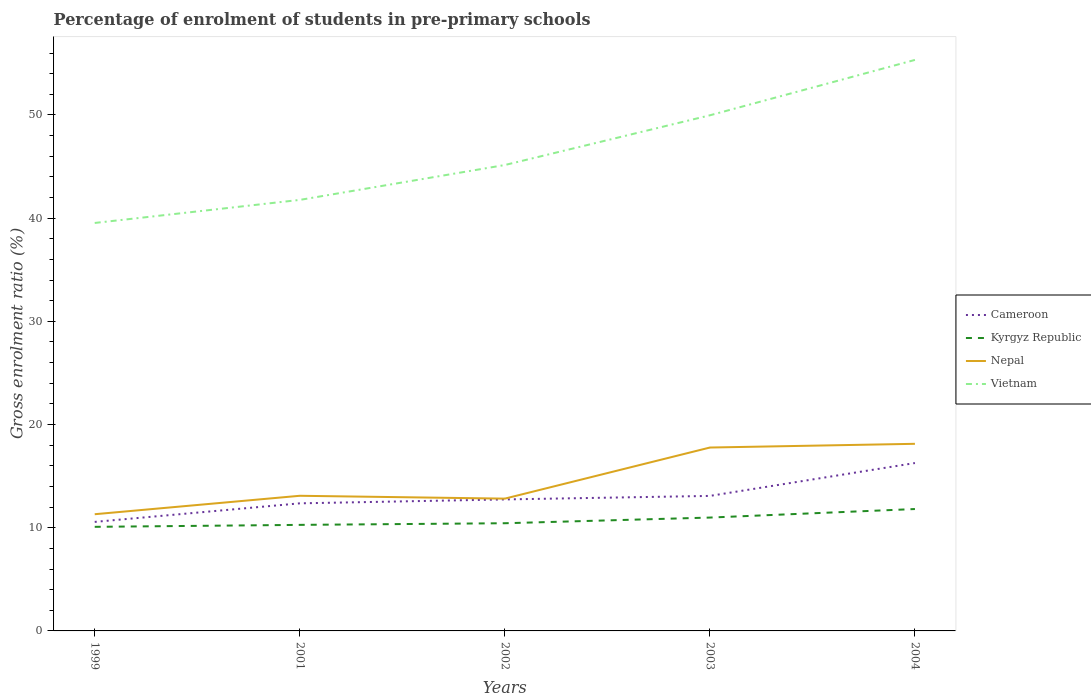How many different coloured lines are there?
Offer a terse response. 4. Across all years, what is the maximum percentage of students enrolled in pre-primary schools in Nepal?
Offer a terse response. 11.31. In which year was the percentage of students enrolled in pre-primary schools in Vietnam maximum?
Offer a terse response. 1999. What is the total percentage of students enrolled in pre-primary schools in Cameroon in the graph?
Give a very brief answer. -3.19. What is the difference between the highest and the second highest percentage of students enrolled in pre-primary schools in Kyrgyz Republic?
Keep it short and to the point. 1.73. Is the percentage of students enrolled in pre-primary schools in Nepal strictly greater than the percentage of students enrolled in pre-primary schools in Kyrgyz Republic over the years?
Make the answer very short. No. How many years are there in the graph?
Keep it short and to the point. 5. What is the difference between two consecutive major ticks on the Y-axis?
Keep it short and to the point. 10. Are the values on the major ticks of Y-axis written in scientific E-notation?
Offer a terse response. No. Does the graph contain grids?
Ensure brevity in your answer.  No. How many legend labels are there?
Your answer should be compact. 4. How are the legend labels stacked?
Provide a short and direct response. Vertical. What is the title of the graph?
Provide a short and direct response. Percentage of enrolment of students in pre-primary schools. Does "Hungary" appear as one of the legend labels in the graph?
Provide a short and direct response. No. What is the label or title of the X-axis?
Ensure brevity in your answer.  Years. What is the label or title of the Y-axis?
Offer a very short reply. Gross enrolment ratio (%). What is the Gross enrolment ratio (%) of Cameroon in 1999?
Provide a short and direct response. 10.56. What is the Gross enrolment ratio (%) in Kyrgyz Republic in 1999?
Give a very brief answer. 10.09. What is the Gross enrolment ratio (%) in Nepal in 1999?
Your answer should be compact. 11.31. What is the Gross enrolment ratio (%) of Vietnam in 1999?
Provide a succinct answer. 39.53. What is the Gross enrolment ratio (%) in Cameroon in 2001?
Keep it short and to the point. 12.36. What is the Gross enrolment ratio (%) in Kyrgyz Republic in 2001?
Your answer should be compact. 10.28. What is the Gross enrolment ratio (%) in Nepal in 2001?
Keep it short and to the point. 13.1. What is the Gross enrolment ratio (%) in Vietnam in 2001?
Make the answer very short. 41.77. What is the Gross enrolment ratio (%) in Cameroon in 2002?
Your answer should be compact. 12.74. What is the Gross enrolment ratio (%) of Kyrgyz Republic in 2002?
Offer a very short reply. 10.44. What is the Gross enrolment ratio (%) in Nepal in 2002?
Ensure brevity in your answer.  12.82. What is the Gross enrolment ratio (%) of Vietnam in 2002?
Offer a terse response. 45.15. What is the Gross enrolment ratio (%) in Cameroon in 2003?
Ensure brevity in your answer.  13.08. What is the Gross enrolment ratio (%) in Kyrgyz Republic in 2003?
Give a very brief answer. 10.99. What is the Gross enrolment ratio (%) of Nepal in 2003?
Offer a very short reply. 17.77. What is the Gross enrolment ratio (%) of Vietnam in 2003?
Your answer should be compact. 49.96. What is the Gross enrolment ratio (%) of Cameroon in 2004?
Provide a succinct answer. 16.27. What is the Gross enrolment ratio (%) in Kyrgyz Republic in 2004?
Provide a short and direct response. 11.81. What is the Gross enrolment ratio (%) of Nepal in 2004?
Provide a short and direct response. 18.13. What is the Gross enrolment ratio (%) in Vietnam in 2004?
Your response must be concise. 55.33. Across all years, what is the maximum Gross enrolment ratio (%) in Cameroon?
Offer a terse response. 16.27. Across all years, what is the maximum Gross enrolment ratio (%) of Kyrgyz Republic?
Your answer should be compact. 11.81. Across all years, what is the maximum Gross enrolment ratio (%) of Nepal?
Your answer should be very brief. 18.13. Across all years, what is the maximum Gross enrolment ratio (%) of Vietnam?
Your answer should be very brief. 55.33. Across all years, what is the minimum Gross enrolment ratio (%) of Cameroon?
Your answer should be very brief. 10.56. Across all years, what is the minimum Gross enrolment ratio (%) in Kyrgyz Republic?
Offer a terse response. 10.09. Across all years, what is the minimum Gross enrolment ratio (%) of Nepal?
Provide a succinct answer. 11.31. Across all years, what is the minimum Gross enrolment ratio (%) in Vietnam?
Your answer should be very brief. 39.53. What is the total Gross enrolment ratio (%) of Cameroon in the graph?
Provide a succinct answer. 65.02. What is the total Gross enrolment ratio (%) of Kyrgyz Republic in the graph?
Offer a very short reply. 53.59. What is the total Gross enrolment ratio (%) of Nepal in the graph?
Keep it short and to the point. 73.13. What is the total Gross enrolment ratio (%) of Vietnam in the graph?
Your answer should be very brief. 231.74. What is the difference between the Gross enrolment ratio (%) in Cameroon in 1999 and that in 2001?
Your response must be concise. -1.8. What is the difference between the Gross enrolment ratio (%) in Kyrgyz Republic in 1999 and that in 2001?
Ensure brevity in your answer.  -0.19. What is the difference between the Gross enrolment ratio (%) of Nepal in 1999 and that in 2001?
Your answer should be very brief. -1.79. What is the difference between the Gross enrolment ratio (%) in Vietnam in 1999 and that in 2001?
Give a very brief answer. -2.23. What is the difference between the Gross enrolment ratio (%) in Cameroon in 1999 and that in 2002?
Ensure brevity in your answer.  -2.18. What is the difference between the Gross enrolment ratio (%) of Kyrgyz Republic in 1999 and that in 2002?
Provide a short and direct response. -0.35. What is the difference between the Gross enrolment ratio (%) of Nepal in 1999 and that in 2002?
Your answer should be compact. -1.51. What is the difference between the Gross enrolment ratio (%) of Vietnam in 1999 and that in 2002?
Provide a succinct answer. -5.61. What is the difference between the Gross enrolment ratio (%) of Cameroon in 1999 and that in 2003?
Your answer should be compact. -2.52. What is the difference between the Gross enrolment ratio (%) of Kyrgyz Republic in 1999 and that in 2003?
Keep it short and to the point. -0.9. What is the difference between the Gross enrolment ratio (%) of Nepal in 1999 and that in 2003?
Your answer should be very brief. -6.46. What is the difference between the Gross enrolment ratio (%) in Vietnam in 1999 and that in 2003?
Provide a short and direct response. -10.43. What is the difference between the Gross enrolment ratio (%) in Cameroon in 1999 and that in 2004?
Make the answer very short. -5.7. What is the difference between the Gross enrolment ratio (%) in Kyrgyz Republic in 1999 and that in 2004?
Your answer should be very brief. -1.73. What is the difference between the Gross enrolment ratio (%) in Nepal in 1999 and that in 2004?
Offer a terse response. -6.82. What is the difference between the Gross enrolment ratio (%) of Vietnam in 1999 and that in 2004?
Provide a succinct answer. -15.8. What is the difference between the Gross enrolment ratio (%) in Cameroon in 2001 and that in 2002?
Provide a short and direct response. -0.38. What is the difference between the Gross enrolment ratio (%) in Kyrgyz Republic in 2001 and that in 2002?
Offer a very short reply. -0.16. What is the difference between the Gross enrolment ratio (%) of Nepal in 2001 and that in 2002?
Keep it short and to the point. 0.28. What is the difference between the Gross enrolment ratio (%) of Vietnam in 2001 and that in 2002?
Provide a short and direct response. -3.38. What is the difference between the Gross enrolment ratio (%) of Cameroon in 2001 and that in 2003?
Your answer should be compact. -0.72. What is the difference between the Gross enrolment ratio (%) of Kyrgyz Republic in 2001 and that in 2003?
Offer a terse response. -0.71. What is the difference between the Gross enrolment ratio (%) in Nepal in 2001 and that in 2003?
Provide a short and direct response. -4.67. What is the difference between the Gross enrolment ratio (%) of Vietnam in 2001 and that in 2003?
Offer a terse response. -8.2. What is the difference between the Gross enrolment ratio (%) in Cameroon in 2001 and that in 2004?
Your answer should be compact. -3.91. What is the difference between the Gross enrolment ratio (%) of Kyrgyz Republic in 2001 and that in 2004?
Your answer should be very brief. -1.54. What is the difference between the Gross enrolment ratio (%) in Nepal in 2001 and that in 2004?
Your answer should be compact. -5.04. What is the difference between the Gross enrolment ratio (%) of Vietnam in 2001 and that in 2004?
Your answer should be very brief. -13.56. What is the difference between the Gross enrolment ratio (%) in Cameroon in 2002 and that in 2003?
Your answer should be compact. -0.34. What is the difference between the Gross enrolment ratio (%) of Kyrgyz Republic in 2002 and that in 2003?
Make the answer very short. -0.55. What is the difference between the Gross enrolment ratio (%) of Nepal in 2002 and that in 2003?
Offer a terse response. -4.95. What is the difference between the Gross enrolment ratio (%) of Vietnam in 2002 and that in 2003?
Give a very brief answer. -4.82. What is the difference between the Gross enrolment ratio (%) in Cameroon in 2002 and that in 2004?
Your answer should be compact. -3.53. What is the difference between the Gross enrolment ratio (%) in Kyrgyz Republic in 2002 and that in 2004?
Offer a terse response. -1.38. What is the difference between the Gross enrolment ratio (%) of Nepal in 2002 and that in 2004?
Your answer should be compact. -5.31. What is the difference between the Gross enrolment ratio (%) of Vietnam in 2002 and that in 2004?
Your response must be concise. -10.18. What is the difference between the Gross enrolment ratio (%) in Cameroon in 2003 and that in 2004?
Offer a very short reply. -3.19. What is the difference between the Gross enrolment ratio (%) of Kyrgyz Republic in 2003 and that in 2004?
Provide a short and direct response. -0.83. What is the difference between the Gross enrolment ratio (%) in Nepal in 2003 and that in 2004?
Your response must be concise. -0.36. What is the difference between the Gross enrolment ratio (%) in Vietnam in 2003 and that in 2004?
Make the answer very short. -5.37. What is the difference between the Gross enrolment ratio (%) in Cameroon in 1999 and the Gross enrolment ratio (%) in Kyrgyz Republic in 2001?
Give a very brief answer. 0.29. What is the difference between the Gross enrolment ratio (%) in Cameroon in 1999 and the Gross enrolment ratio (%) in Nepal in 2001?
Offer a very short reply. -2.53. What is the difference between the Gross enrolment ratio (%) of Cameroon in 1999 and the Gross enrolment ratio (%) of Vietnam in 2001?
Your answer should be very brief. -31.2. What is the difference between the Gross enrolment ratio (%) of Kyrgyz Republic in 1999 and the Gross enrolment ratio (%) of Nepal in 2001?
Provide a succinct answer. -3.01. What is the difference between the Gross enrolment ratio (%) in Kyrgyz Republic in 1999 and the Gross enrolment ratio (%) in Vietnam in 2001?
Offer a very short reply. -31.68. What is the difference between the Gross enrolment ratio (%) in Nepal in 1999 and the Gross enrolment ratio (%) in Vietnam in 2001?
Ensure brevity in your answer.  -30.46. What is the difference between the Gross enrolment ratio (%) of Cameroon in 1999 and the Gross enrolment ratio (%) of Kyrgyz Republic in 2002?
Give a very brief answer. 0.13. What is the difference between the Gross enrolment ratio (%) in Cameroon in 1999 and the Gross enrolment ratio (%) in Nepal in 2002?
Offer a very short reply. -2.26. What is the difference between the Gross enrolment ratio (%) in Cameroon in 1999 and the Gross enrolment ratio (%) in Vietnam in 2002?
Give a very brief answer. -34.58. What is the difference between the Gross enrolment ratio (%) of Kyrgyz Republic in 1999 and the Gross enrolment ratio (%) of Nepal in 2002?
Ensure brevity in your answer.  -2.73. What is the difference between the Gross enrolment ratio (%) of Kyrgyz Republic in 1999 and the Gross enrolment ratio (%) of Vietnam in 2002?
Make the answer very short. -35.06. What is the difference between the Gross enrolment ratio (%) in Nepal in 1999 and the Gross enrolment ratio (%) in Vietnam in 2002?
Your response must be concise. -33.84. What is the difference between the Gross enrolment ratio (%) in Cameroon in 1999 and the Gross enrolment ratio (%) in Kyrgyz Republic in 2003?
Your answer should be compact. -0.42. What is the difference between the Gross enrolment ratio (%) in Cameroon in 1999 and the Gross enrolment ratio (%) in Nepal in 2003?
Your response must be concise. -7.21. What is the difference between the Gross enrolment ratio (%) in Cameroon in 1999 and the Gross enrolment ratio (%) in Vietnam in 2003?
Keep it short and to the point. -39.4. What is the difference between the Gross enrolment ratio (%) in Kyrgyz Republic in 1999 and the Gross enrolment ratio (%) in Nepal in 2003?
Provide a short and direct response. -7.68. What is the difference between the Gross enrolment ratio (%) in Kyrgyz Republic in 1999 and the Gross enrolment ratio (%) in Vietnam in 2003?
Offer a terse response. -39.88. What is the difference between the Gross enrolment ratio (%) in Nepal in 1999 and the Gross enrolment ratio (%) in Vietnam in 2003?
Provide a succinct answer. -38.66. What is the difference between the Gross enrolment ratio (%) in Cameroon in 1999 and the Gross enrolment ratio (%) in Kyrgyz Republic in 2004?
Ensure brevity in your answer.  -1.25. What is the difference between the Gross enrolment ratio (%) of Cameroon in 1999 and the Gross enrolment ratio (%) of Nepal in 2004?
Provide a succinct answer. -7.57. What is the difference between the Gross enrolment ratio (%) in Cameroon in 1999 and the Gross enrolment ratio (%) in Vietnam in 2004?
Offer a very short reply. -44.77. What is the difference between the Gross enrolment ratio (%) in Kyrgyz Republic in 1999 and the Gross enrolment ratio (%) in Nepal in 2004?
Keep it short and to the point. -8.04. What is the difference between the Gross enrolment ratio (%) in Kyrgyz Republic in 1999 and the Gross enrolment ratio (%) in Vietnam in 2004?
Give a very brief answer. -45.25. What is the difference between the Gross enrolment ratio (%) of Nepal in 1999 and the Gross enrolment ratio (%) of Vietnam in 2004?
Provide a short and direct response. -44.02. What is the difference between the Gross enrolment ratio (%) of Cameroon in 2001 and the Gross enrolment ratio (%) of Kyrgyz Republic in 2002?
Keep it short and to the point. 1.93. What is the difference between the Gross enrolment ratio (%) of Cameroon in 2001 and the Gross enrolment ratio (%) of Nepal in 2002?
Make the answer very short. -0.46. What is the difference between the Gross enrolment ratio (%) in Cameroon in 2001 and the Gross enrolment ratio (%) in Vietnam in 2002?
Offer a very short reply. -32.78. What is the difference between the Gross enrolment ratio (%) of Kyrgyz Republic in 2001 and the Gross enrolment ratio (%) of Nepal in 2002?
Provide a short and direct response. -2.54. What is the difference between the Gross enrolment ratio (%) in Kyrgyz Republic in 2001 and the Gross enrolment ratio (%) in Vietnam in 2002?
Give a very brief answer. -34.87. What is the difference between the Gross enrolment ratio (%) of Nepal in 2001 and the Gross enrolment ratio (%) of Vietnam in 2002?
Offer a very short reply. -32.05. What is the difference between the Gross enrolment ratio (%) in Cameroon in 2001 and the Gross enrolment ratio (%) in Kyrgyz Republic in 2003?
Your response must be concise. 1.38. What is the difference between the Gross enrolment ratio (%) in Cameroon in 2001 and the Gross enrolment ratio (%) in Nepal in 2003?
Offer a very short reply. -5.41. What is the difference between the Gross enrolment ratio (%) in Cameroon in 2001 and the Gross enrolment ratio (%) in Vietnam in 2003?
Make the answer very short. -37.6. What is the difference between the Gross enrolment ratio (%) in Kyrgyz Republic in 2001 and the Gross enrolment ratio (%) in Nepal in 2003?
Your answer should be very brief. -7.49. What is the difference between the Gross enrolment ratio (%) of Kyrgyz Republic in 2001 and the Gross enrolment ratio (%) of Vietnam in 2003?
Your answer should be very brief. -39.69. What is the difference between the Gross enrolment ratio (%) of Nepal in 2001 and the Gross enrolment ratio (%) of Vietnam in 2003?
Your response must be concise. -36.87. What is the difference between the Gross enrolment ratio (%) in Cameroon in 2001 and the Gross enrolment ratio (%) in Kyrgyz Republic in 2004?
Offer a terse response. 0.55. What is the difference between the Gross enrolment ratio (%) of Cameroon in 2001 and the Gross enrolment ratio (%) of Nepal in 2004?
Your response must be concise. -5.77. What is the difference between the Gross enrolment ratio (%) of Cameroon in 2001 and the Gross enrolment ratio (%) of Vietnam in 2004?
Offer a very short reply. -42.97. What is the difference between the Gross enrolment ratio (%) of Kyrgyz Republic in 2001 and the Gross enrolment ratio (%) of Nepal in 2004?
Provide a succinct answer. -7.86. What is the difference between the Gross enrolment ratio (%) of Kyrgyz Republic in 2001 and the Gross enrolment ratio (%) of Vietnam in 2004?
Provide a short and direct response. -45.06. What is the difference between the Gross enrolment ratio (%) in Nepal in 2001 and the Gross enrolment ratio (%) in Vietnam in 2004?
Offer a very short reply. -42.24. What is the difference between the Gross enrolment ratio (%) of Cameroon in 2002 and the Gross enrolment ratio (%) of Kyrgyz Republic in 2003?
Offer a terse response. 1.76. What is the difference between the Gross enrolment ratio (%) in Cameroon in 2002 and the Gross enrolment ratio (%) in Nepal in 2003?
Your answer should be compact. -5.03. What is the difference between the Gross enrolment ratio (%) in Cameroon in 2002 and the Gross enrolment ratio (%) in Vietnam in 2003?
Provide a succinct answer. -37.22. What is the difference between the Gross enrolment ratio (%) in Kyrgyz Republic in 2002 and the Gross enrolment ratio (%) in Nepal in 2003?
Your answer should be very brief. -7.34. What is the difference between the Gross enrolment ratio (%) of Kyrgyz Republic in 2002 and the Gross enrolment ratio (%) of Vietnam in 2003?
Make the answer very short. -39.53. What is the difference between the Gross enrolment ratio (%) of Nepal in 2002 and the Gross enrolment ratio (%) of Vietnam in 2003?
Your answer should be compact. -37.14. What is the difference between the Gross enrolment ratio (%) in Cameroon in 2002 and the Gross enrolment ratio (%) in Kyrgyz Republic in 2004?
Make the answer very short. 0.93. What is the difference between the Gross enrolment ratio (%) in Cameroon in 2002 and the Gross enrolment ratio (%) in Nepal in 2004?
Your answer should be compact. -5.39. What is the difference between the Gross enrolment ratio (%) of Cameroon in 2002 and the Gross enrolment ratio (%) of Vietnam in 2004?
Keep it short and to the point. -42.59. What is the difference between the Gross enrolment ratio (%) in Kyrgyz Republic in 2002 and the Gross enrolment ratio (%) in Nepal in 2004?
Give a very brief answer. -7.7. What is the difference between the Gross enrolment ratio (%) in Kyrgyz Republic in 2002 and the Gross enrolment ratio (%) in Vietnam in 2004?
Offer a very short reply. -44.9. What is the difference between the Gross enrolment ratio (%) in Nepal in 2002 and the Gross enrolment ratio (%) in Vietnam in 2004?
Offer a very short reply. -42.51. What is the difference between the Gross enrolment ratio (%) in Cameroon in 2003 and the Gross enrolment ratio (%) in Kyrgyz Republic in 2004?
Make the answer very short. 1.27. What is the difference between the Gross enrolment ratio (%) in Cameroon in 2003 and the Gross enrolment ratio (%) in Nepal in 2004?
Provide a succinct answer. -5.05. What is the difference between the Gross enrolment ratio (%) in Cameroon in 2003 and the Gross enrolment ratio (%) in Vietnam in 2004?
Offer a very short reply. -42.25. What is the difference between the Gross enrolment ratio (%) of Kyrgyz Republic in 2003 and the Gross enrolment ratio (%) of Nepal in 2004?
Your answer should be compact. -7.15. What is the difference between the Gross enrolment ratio (%) in Kyrgyz Republic in 2003 and the Gross enrolment ratio (%) in Vietnam in 2004?
Keep it short and to the point. -44.35. What is the difference between the Gross enrolment ratio (%) of Nepal in 2003 and the Gross enrolment ratio (%) of Vietnam in 2004?
Give a very brief answer. -37.56. What is the average Gross enrolment ratio (%) in Cameroon per year?
Your answer should be compact. 13. What is the average Gross enrolment ratio (%) of Kyrgyz Republic per year?
Provide a succinct answer. 10.72. What is the average Gross enrolment ratio (%) in Nepal per year?
Keep it short and to the point. 14.63. What is the average Gross enrolment ratio (%) of Vietnam per year?
Provide a short and direct response. 46.35. In the year 1999, what is the difference between the Gross enrolment ratio (%) in Cameroon and Gross enrolment ratio (%) in Kyrgyz Republic?
Keep it short and to the point. 0.48. In the year 1999, what is the difference between the Gross enrolment ratio (%) in Cameroon and Gross enrolment ratio (%) in Nepal?
Provide a succinct answer. -0.74. In the year 1999, what is the difference between the Gross enrolment ratio (%) in Cameroon and Gross enrolment ratio (%) in Vietnam?
Provide a short and direct response. -28.97. In the year 1999, what is the difference between the Gross enrolment ratio (%) of Kyrgyz Republic and Gross enrolment ratio (%) of Nepal?
Provide a short and direct response. -1.22. In the year 1999, what is the difference between the Gross enrolment ratio (%) of Kyrgyz Republic and Gross enrolment ratio (%) of Vietnam?
Ensure brevity in your answer.  -29.45. In the year 1999, what is the difference between the Gross enrolment ratio (%) of Nepal and Gross enrolment ratio (%) of Vietnam?
Keep it short and to the point. -28.22. In the year 2001, what is the difference between the Gross enrolment ratio (%) in Cameroon and Gross enrolment ratio (%) in Kyrgyz Republic?
Your response must be concise. 2.09. In the year 2001, what is the difference between the Gross enrolment ratio (%) of Cameroon and Gross enrolment ratio (%) of Nepal?
Offer a terse response. -0.73. In the year 2001, what is the difference between the Gross enrolment ratio (%) of Cameroon and Gross enrolment ratio (%) of Vietnam?
Your answer should be very brief. -29.4. In the year 2001, what is the difference between the Gross enrolment ratio (%) in Kyrgyz Republic and Gross enrolment ratio (%) in Nepal?
Offer a very short reply. -2.82. In the year 2001, what is the difference between the Gross enrolment ratio (%) in Kyrgyz Republic and Gross enrolment ratio (%) in Vietnam?
Keep it short and to the point. -31.49. In the year 2001, what is the difference between the Gross enrolment ratio (%) of Nepal and Gross enrolment ratio (%) of Vietnam?
Your response must be concise. -28.67. In the year 2002, what is the difference between the Gross enrolment ratio (%) of Cameroon and Gross enrolment ratio (%) of Kyrgyz Republic?
Provide a short and direct response. 2.31. In the year 2002, what is the difference between the Gross enrolment ratio (%) of Cameroon and Gross enrolment ratio (%) of Nepal?
Keep it short and to the point. -0.08. In the year 2002, what is the difference between the Gross enrolment ratio (%) of Cameroon and Gross enrolment ratio (%) of Vietnam?
Offer a terse response. -32.41. In the year 2002, what is the difference between the Gross enrolment ratio (%) in Kyrgyz Republic and Gross enrolment ratio (%) in Nepal?
Give a very brief answer. -2.38. In the year 2002, what is the difference between the Gross enrolment ratio (%) in Kyrgyz Republic and Gross enrolment ratio (%) in Vietnam?
Make the answer very short. -34.71. In the year 2002, what is the difference between the Gross enrolment ratio (%) of Nepal and Gross enrolment ratio (%) of Vietnam?
Offer a terse response. -32.33. In the year 2003, what is the difference between the Gross enrolment ratio (%) of Cameroon and Gross enrolment ratio (%) of Kyrgyz Republic?
Ensure brevity in your answer.  2.1. In the year 2003, what is the difference between the Gross enrolment ratio (%) of Cameroon and Gross enrolment ratio (%) of Nepal?
Provide a succinct answer. -4.69. In the year 2003, what is the difference between the Gross enrolment ratio (%) in Cameroon and Gross enrolment ratio (%) in Vietnam?
Make the answer very short. -36.88. In the year 2003, what is the difference between the Gross enrolment ratio (%) of Kyrgyz Republic and Gross enrolment ratio (%) of Nepal?
Offer a terse response. -6.79. In the year 2003, what is the difference between the Gross enrolment ratio (%) of Kyrgyz Republic and Gross enrolment ratio (%) of Vietnam?
Provide a short and direct response. -38.98. In the year 2003, what is the difference between the Gross enrolment ratio (%) of Nepal and Gross enrolment ratio (%) of Vietnam?
Offer a very short reply. -32.19. In the year 2004, what is the difference between the Gross enrolment ratio (%) of Cameroon and Gross enrolment ratio (%) of Kyrgyz Republic?
Your answer should be compact. 4.46. In the year 2004, what is the difference between the Gross enrolment ratio (%) of Cameroon and Gross enrolment ratio (%) of Nepal?
Your response must be concise. -1.86. In the year 2004, what is the difference between the Gross enrolment ratio (%) of Cameroon and Gross enrolment ratio (%) of Vietnam?
Your answer should be compact. -39.06. In the year 2004, what is the difference between the Gross enrolment ratio (%) in Kyrgyz Republic and Gross enrolment ratio (%) in Nepal?
Provide a short and direct response. -6.32. In the year 2004, what is the difference between the Gross enrolment ratio (%) of Kyrgyz Republic and Gross enrolment ratio (%) of Vietnam?
Ensure brevity in your answer.  -43.52. In the year 2004, what is the difference between the Gross enrolment ratio (%) of Nepal and Gross enrolment ratio (%) of Vietnam?
Give a very brief answer. -37.2. What is the ratio of the Gross enrolment ratio (%) in Cameroon in 1999 to that in 2001?
Make the answer very short. 0.85. What is the ratio of the Gross enrolment ratio (%) in Kyrgyz Republic in 1999 to that in 2001?
Keep it short and to the point. 0.98. What is the ratio of the Gross enrolment ratio (%) in Nepal in 1999 to that in 2001?
Make the answer very short. 0.86. What is the ratio of the Gross enrolment ratio (%) in Vietnam in 1999 to that in 2001?
Ensure brevity in your answer.  0.95. What is the ratio of the Gross enrolment ratio (%) of Cameroon in 1999 to that in 2002?
Make the answer very short. 0.83. What is the ratio of the Gross enrolment ratio (%) of Kyrgyz Republic in 1999 to that in 2002?
Provide a succinct answer. 0.97. What is the ratio of the Gross enrolment ratio (%) in Nepal in 1999 to that in 2002?
Your response must be concise. 0.88. What is the ratio of the Gross enrolment ratio (%) in Vietnam in 1999 to that in 2002?
Your answer should be compact. 0.88. What is the ratio of the Gross enrolment ratio (%) of Cameroon in 1999 to that in 2003?
Offer a terse response. 0.81. What is the ratio of the Gross enrolment ratio (%) of Kyrgyz Republic in 1999 to that in 2003?
Your answer should be compact. 0.92. What is the ratio of the Gross enrolment ratio (%) of Nepal in 1999 to that in 2003?
Give a very brief answer. 0.64. What is the ratio of the Gross enrolment ratio (%) of Vietnam in 1999 to that in 2003?
Offer a terse response. 0.79. What is the ratio of the Gross enrolment ratio (%) in Cameroon in 1999 to that in 2004?
Offer a very short reply. 0.65. What is the ratio of the Gross enrolment ratio (%) in Kyrgyz Republic in 1999 to that in 2004?
Your answer should be very brief. 0.85. What is the ratio of the Gross enrolment ratio (%) in Nepal in 1999 to that in 2004?
Make the answer very short. 0.62. What is the ratio of the Gross enrolment ratio (%) of Vietnam in 1999 to that in 2004?
Offer a terse response. 0.71. What is the ratio of the Gross enrolment ratio (%) in Cameroon in 2001 to that in 2002?
Your answer should be very brief. 0.97. What is the ratio of the Gross enrolment ratio (%) in Nepal in 2001 to that in 2002?
Give a very brief answer. 1.02. What is the ratio of the Gross enrolment ratio (%) of Vietnam in 2001 to that in 2002?
Your answer should be very brief. 0.93. What is the ratio of the Gross enrolment ratio (%) of Cameroon in 2001 to that in 2003?
Offer a very short reply. 0.94. What is the ratio of the Gross enrolment ratio (%) of Kyrgyz Republic in 2001 to that in 2003?
Provide a succinct answer. 0.94. What is the ratio of the Gross enrolment ratio (%) in Nepal in 2001 to that in 2003?
Make the answer very short. 0.74. What is the ratio of the Gross enrolment ratio (%) of Vietnam in 2001 to that in 2003?
Keep it short and to the point. 0.84. What is the ratio of the Gross enrolment ratio (%) in Cameroon in 2001 to that in 2004?
Provide a succinct answer. 0.76. What is the ratio of the Gross enrolment ratio (%) of Kyrgyz Republic in 2001 to that in 2004?
Provide a short and direct response. 0.87. What is the ratio of the Gross enrolment ratio (%) of Nepal in 2001 to that in 2004?
Your answer should be very brief. 0.72. What is the ratio of the Gross enrolment ratio (%) in Vietnam in 2001 to that in 2004?
Give a very brief answer. 0.75. What is the ratio of the Gross enrolment ratio (%) of Cameroon in 2002 to that in 2003?
Offer a very short reply. 0.97. What is the ratio of the Gross enrolment ratio (%) in Kyrgyz Republic in 2002 to that in 2003?
Keep it short and to the point. 0.95. What is the ratio of the Gross enrolment ratio (%) of Nepal in 2002 to that in 2003?
Provide a short and direct response. 0.72. What is the ratio of the Gross enrolment ratio (%) of Vietnam in 2002 to that in 2003?
Offer a terse response. 0.9. What is the ratio of the Gross enrolment ratio (%) in Cameroon in 2002 to that in 2004?
Offer a terse response. 0.78. What is the ratio of the Gross enrolment ratio (%) of Kyrgyz Republic in 2002 to that in 2004?
Keep it short and to the point. 0.88. What is the ratio of the Gross enrolment ratio (%) of Nepal in 2002 to that in 2004?
Offer a very short reply. 0.71. What is the ratio of the Gross enrolment ratio (%) of Vietnam in 2002 to that in 2004?
Offer a very short reply. 0.82. What is the ratio of the Gross enrolment ratio (%) of Cameroon in 2003 to that in 2004?
Your response must be concise. 0.8. What is the ratio of the Gross enrolment ratio (%) of Kyrgyz Republic in 2003 to that in 2004?
Provide a succinct answer. 0.93. What is the ratio of the Gross enrolment ratio (%) in Nepal in 2003 to that in 2004?
Give a very brief answer. 0.98. What is the ratio of the Gross enrolment ratio (%) in Vietnam in 2003 to that in 2004?
Provide a short and direct response. 0.9. What is the difference between the highest and the second highest Gross enrolment ratio (%) in Cameroon?
Provide a succinct answer. 3.19. What is the difference between the highest and the second highest Gross enrolment ratio (%) of Kyrgyz Republic?
Keep it short and to the point. 0.83. What is the difference between the highest and the second highest Gross enrolment ratio (%) of Nepal?
Give a very brief answer. 0.36. What is the difference between the highest and the second highest Gross enrolment ratio (%) in Vietnam?
Your answer should be very brief. 5.37. What is the difference between the highest and the lowest Gross enrolment ratio (%) in Cameroon?
Offer a very short reply. 5.7. What is the difference between the highest and the lowest Gross enrolment ratio (%) in Kyrgyz Republic?
Give a very brief answer. 1.73. What is the difference between the highest and the lowest Gross enrolment ratio (%) in Nepal?
Offer a terse response. 6.82. What is the difference between the highest and the lowest Gross enrolment ratio (%) in Vietnam?
Give a very brief answer. 15.8. 